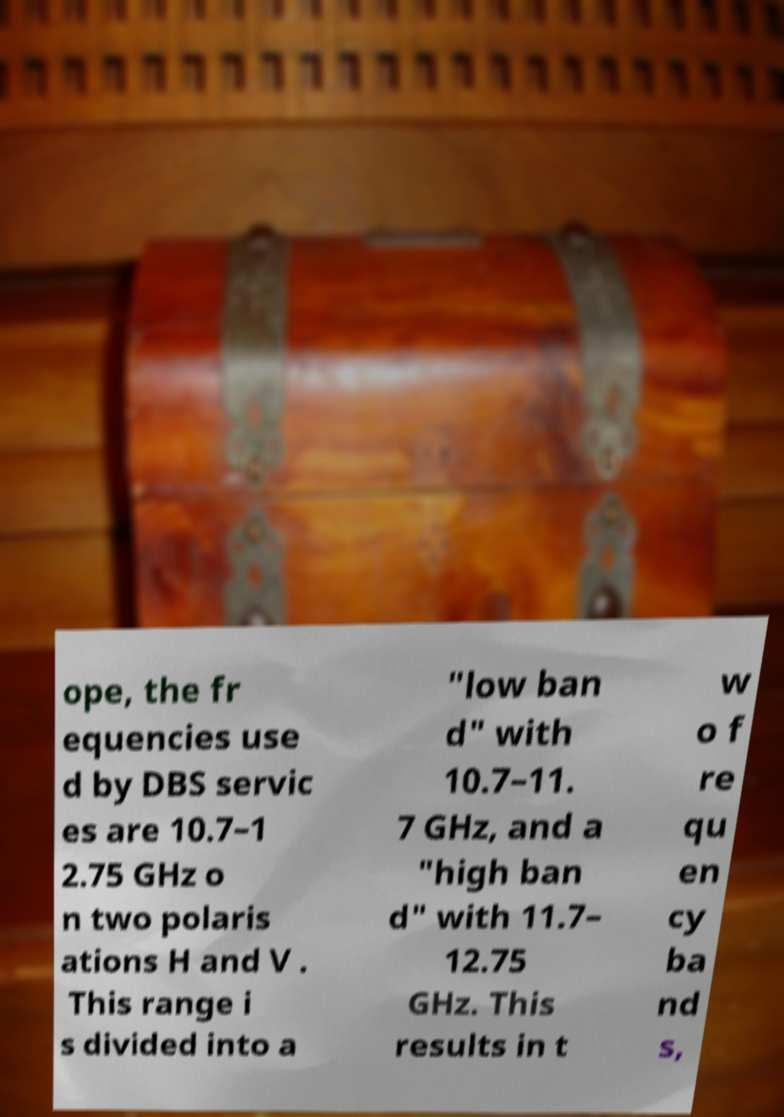Could you extract and type out the text from this image? ope, the fr equencies use d by DBS servic es are 10.7–1 2.75 GHz o n two polaris ations H and V . This range i s divided into a "low ban d" with 10.7–11. 7 GHz, and a "high ban d" with 11.7– 12.75 GHz. This results in t w o f re qu en cy ba nd s, 